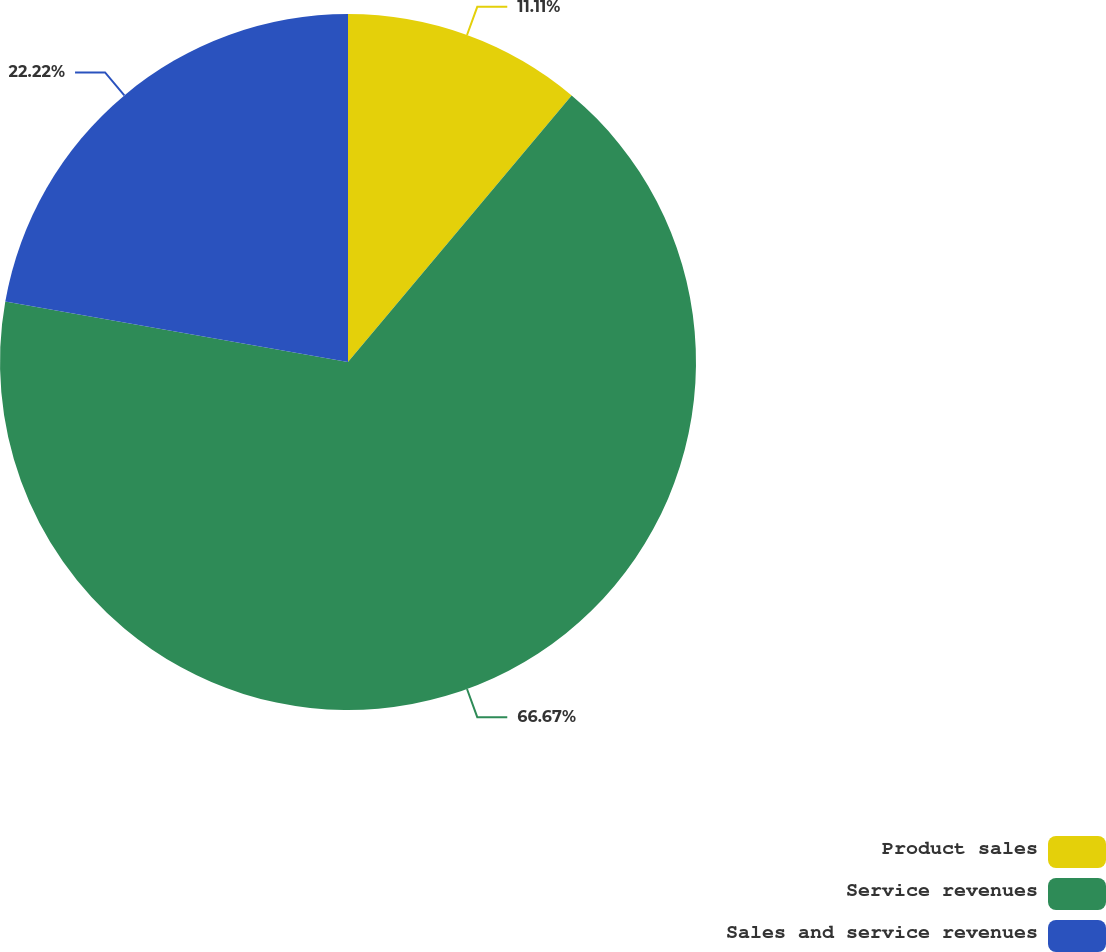Convert chart to OTSL. <chart><loc_0><loc_0><loc_500><loc_500><pie_chart><fcel>Product sales<fcel>Service revenues<fcel>Sales and service revenues<nl><fcel>11.11%<fcel>66.67%<fcel>22.22%<nl></chart> 